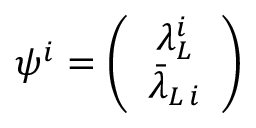<formula> <loc_0><loc_0><loc_500><loc_500>\psi ^ { i } = \left ( \begin{array} { c } { { \lambda _ { L } ^ { i } } } \\ { { \bar { \lambda } _ { L \, i } } } \end{array} \right )</formula> 